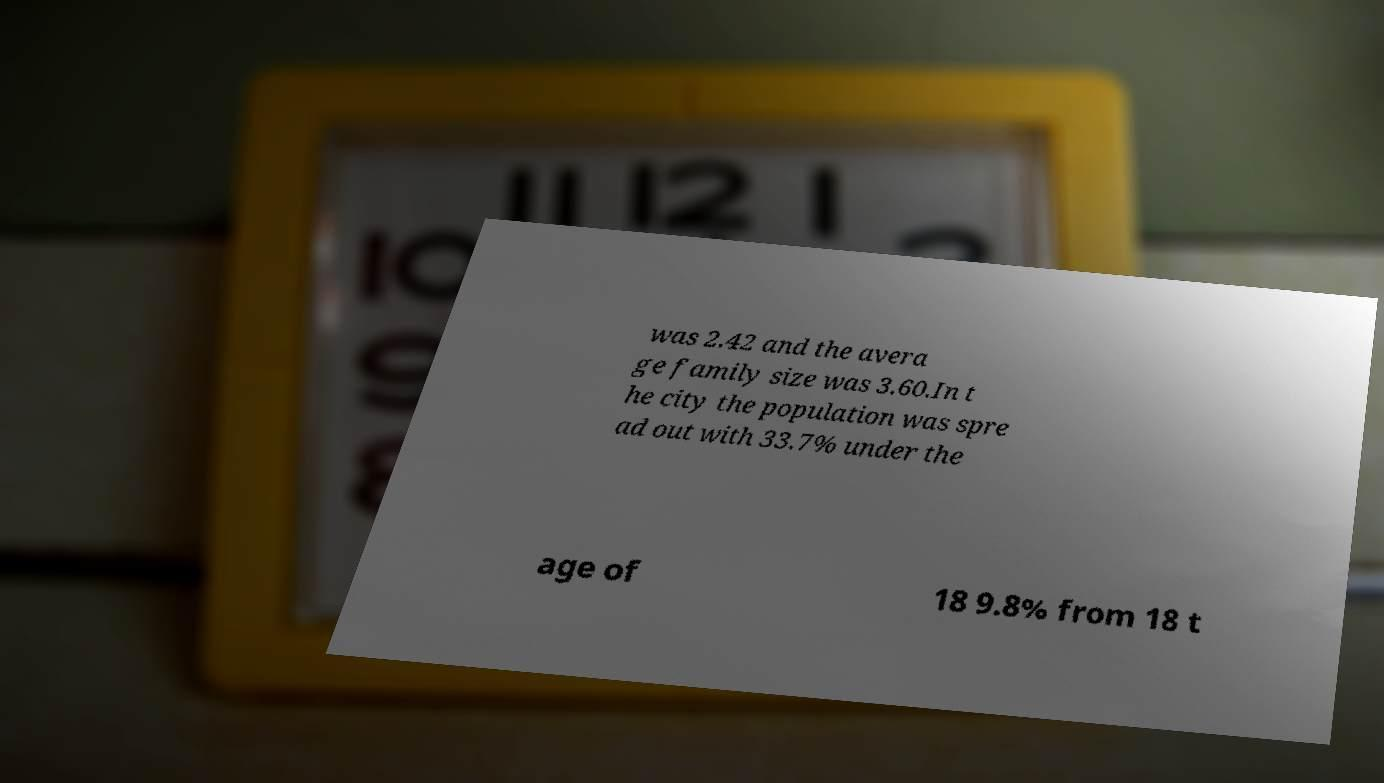Please identify and transcribe the text found in this image. was 2.42 and the avera ge family size was 3.60.In t he city the population was spre ad out with 33.7% under the age of 18 9.8% from 18 t 